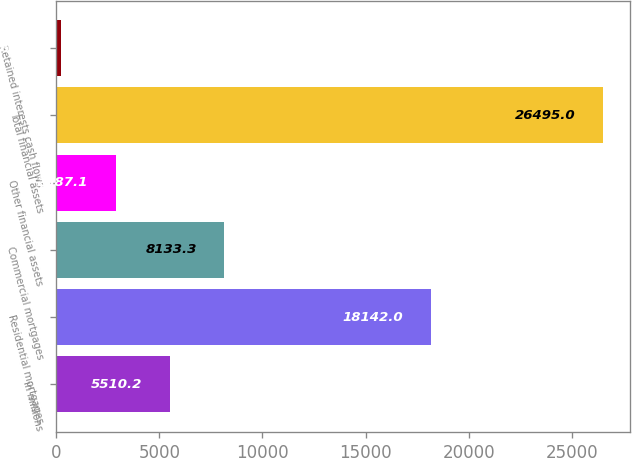<chart> <loc_0><loc_0><loc_500><loc_500><bar_chart><fcel>in millions<fcel>Residential mortgages<fcel>Commercial mortgages<fcel>Other financial assets<fcel>Total financial assets<fcel>Retained interests cash flows<nl><fcel>5510.2<fcel>18142<fcel>8133.3<fcel>2887.1<fcel>26495<fcel>264<nl></chart> 